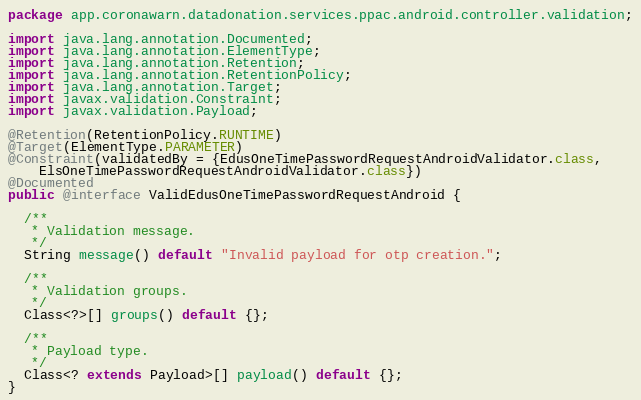Convert code to text. <code><loc_0><loc_0><loc_500><loc_500><_Java_>package app.coronawarn.datadonation.services.ppac.android.controller.validation;

import java.lang.annotation.Documented;
import java.lang.annotation.ElementType;
import java.lang.annotation.Retention;
import java.lang.annotation.RetentionPolicy;
import java.lang.annotation.Target;
import javax.validation.Constraint;
import javax.validation.Payload;

@Retention(RetentionPolicy.RUNTIME)
@Target(ElementType.PARAMETER)
@Constraint(validatedBy = {EdusOneTimePasswordRequestAndroidValidator.class,
    ElsOneTimePasswordRequestAndroidValidator.class})
@Documented
public @interface ValidEdusOneTimePasswordRequestAndroid {

  /**
   * Validation message.
   */
  String message() default "Invalid payload for otp creation.";

  /**
   * Validation groups.
   */
  Class<?>[] groups() default {};

  /**
   * Payload type.
   */
  Class<? extends Payload>[] payload() default {};
}
</code> 